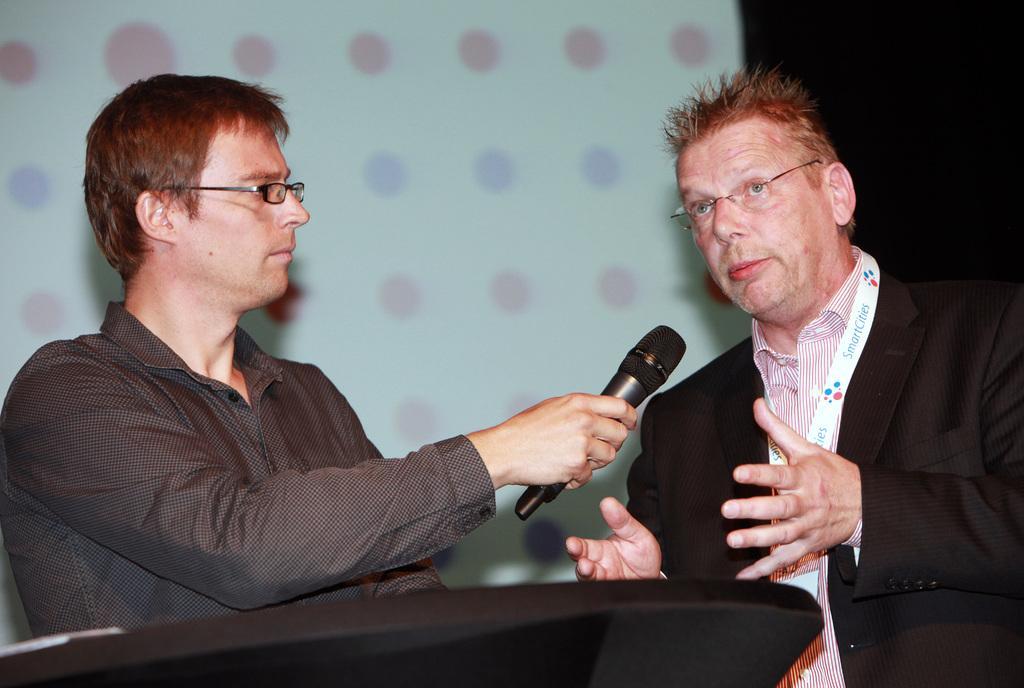How would you summarize this image in a sentence or two? In this picture there are two men, one man towards the left, he is wearing a black shirt and spectacles, holding a mike ,towards the right there is another wearing black blazer, strip shirt and spectacles. In the background there is a screen. In the bottom there is a podium. 